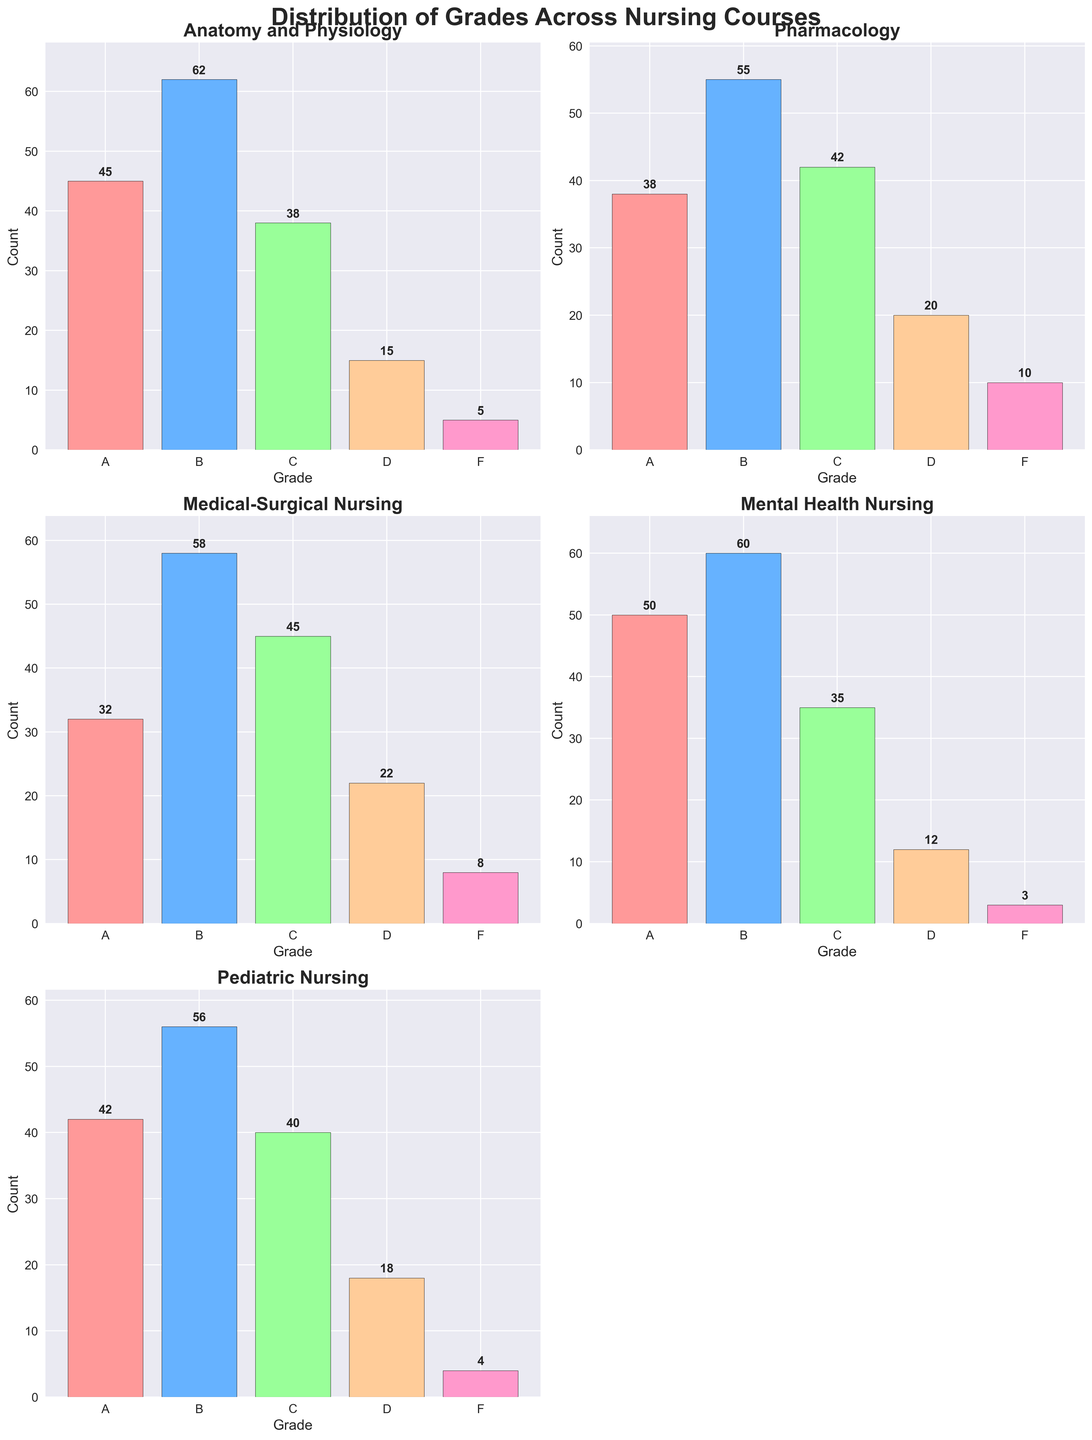Which course has the highest number of A grades? By looking at the subplot for each course, the course Mental Health Nursing has the highest count of A grades, which is 50.
Answer: Mental Health Nursing What is the total number of D grades across all courses? Add the number of D grades from each subplot: 15 (Anatomy and Physiology) + 20 (Pharmacology) + 22 (Medical-Surgical Nursing) + 12 (Mental Health Nursing) + 18 (Pediatric Nursing) = 87.
Answer: 87 Which course has the lowest count of F grades? By checking each subplot for the count of F grades, Mental Health Nursing has the lowest number with 3.
Answer: Mental Health Nursing Which course has the highest total count of grades combined? Add all the counts for each course and compare. The total counts are: 
Anatomy and Physiology (165), 
Pharmacology (165), 
Medical-Surgical Nursing (165), 
Mental Health Nursing (160), 
Pediatric Nursing (160). The highest counts are shared by Anatomy and Physiology, Pharmacology, and Medical-Surgical Nursing, each with 165.
Answer: Anatomy and Physiology, Pharmacology, Medical-Surgical Nursing How many more B grades are there in Pediatric Nursing compared to Medical-Surgical Nursing? There are 56 B grades in Pediatric Nursing and 58 in Medical-Surgical Nursing. The difference is 56 - 58 = -2. Thus, there are 2 fewer B grades in Pediatric Nursing than in Medical-Surgical Nursing.
Answer: -2 (2 fewer) What is the average number of C grades across all courses? First, find the total count of C grades: 38 (Anatomy and Physiology) + 42 (Pharmacology) + 45 (Medical-Surgical Nursing) + 35 (Mental Health Nursing) + 40 (Pediatric Nursing) = 200. Then divide by the number of courses: 200 / 5 = 40.
Answer: 40 Which grade is the least common in Anatomy and Physiology? By looking at the subplot for Anatomy and Physiology, F grades have the lowest count with just 5.
Answer: F In Pharmacology, what is the sum of the counts for A and B grades? The counts for A and B grades in Pharmacology are 38 and 55, respectively. The sum is 38 + 55 = 93.
Answer: 93 